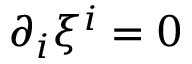<formula> <loc_0><loc_0><loc_500><loc_500>\partial _ { i } \xi ^ { i } = 0</formula> 